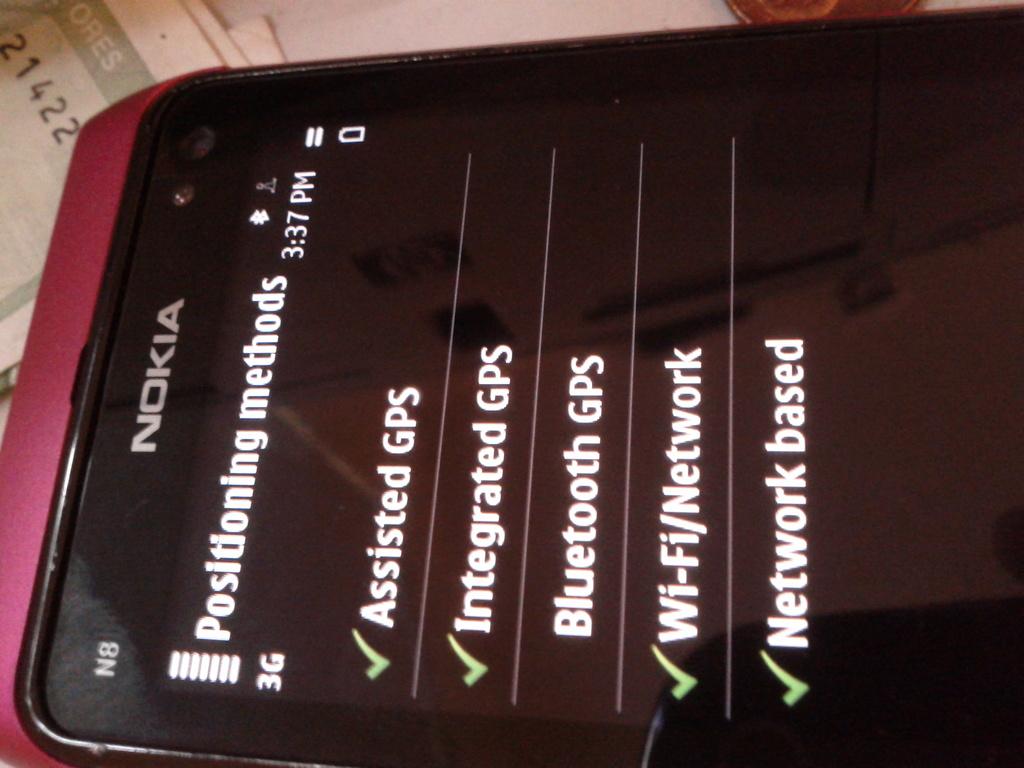What brand is this phone?
Keep it short and to the point. Nokia. Is this a phone settings?
Keep it short and to the point. Yes. 